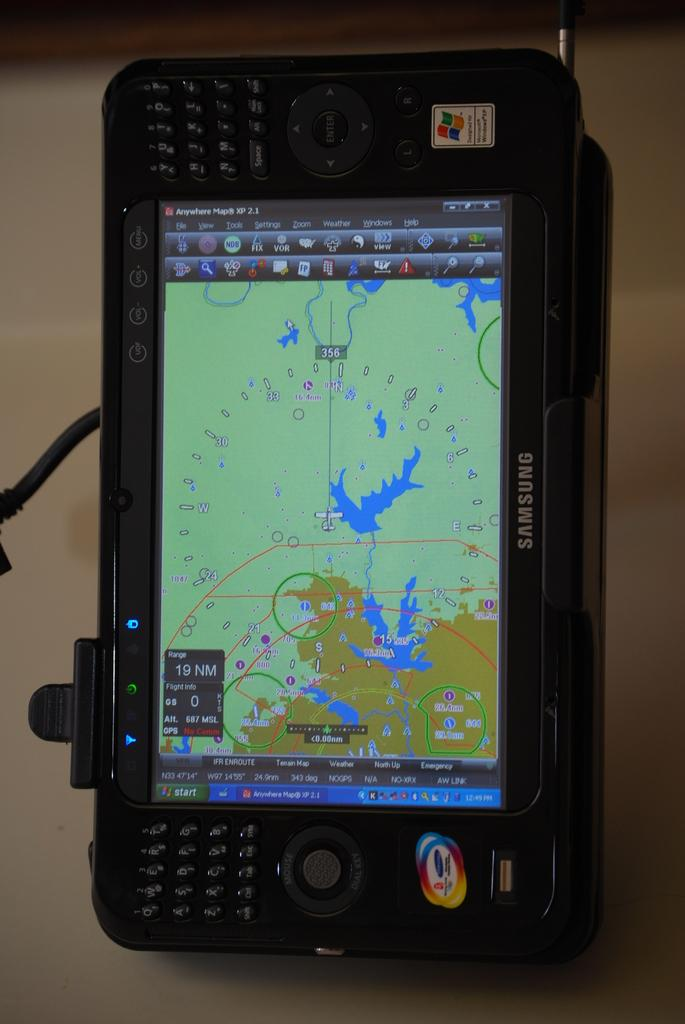<image>
Render a clear and concise summary of the photo. A Samsung device showing a map on its screen. 